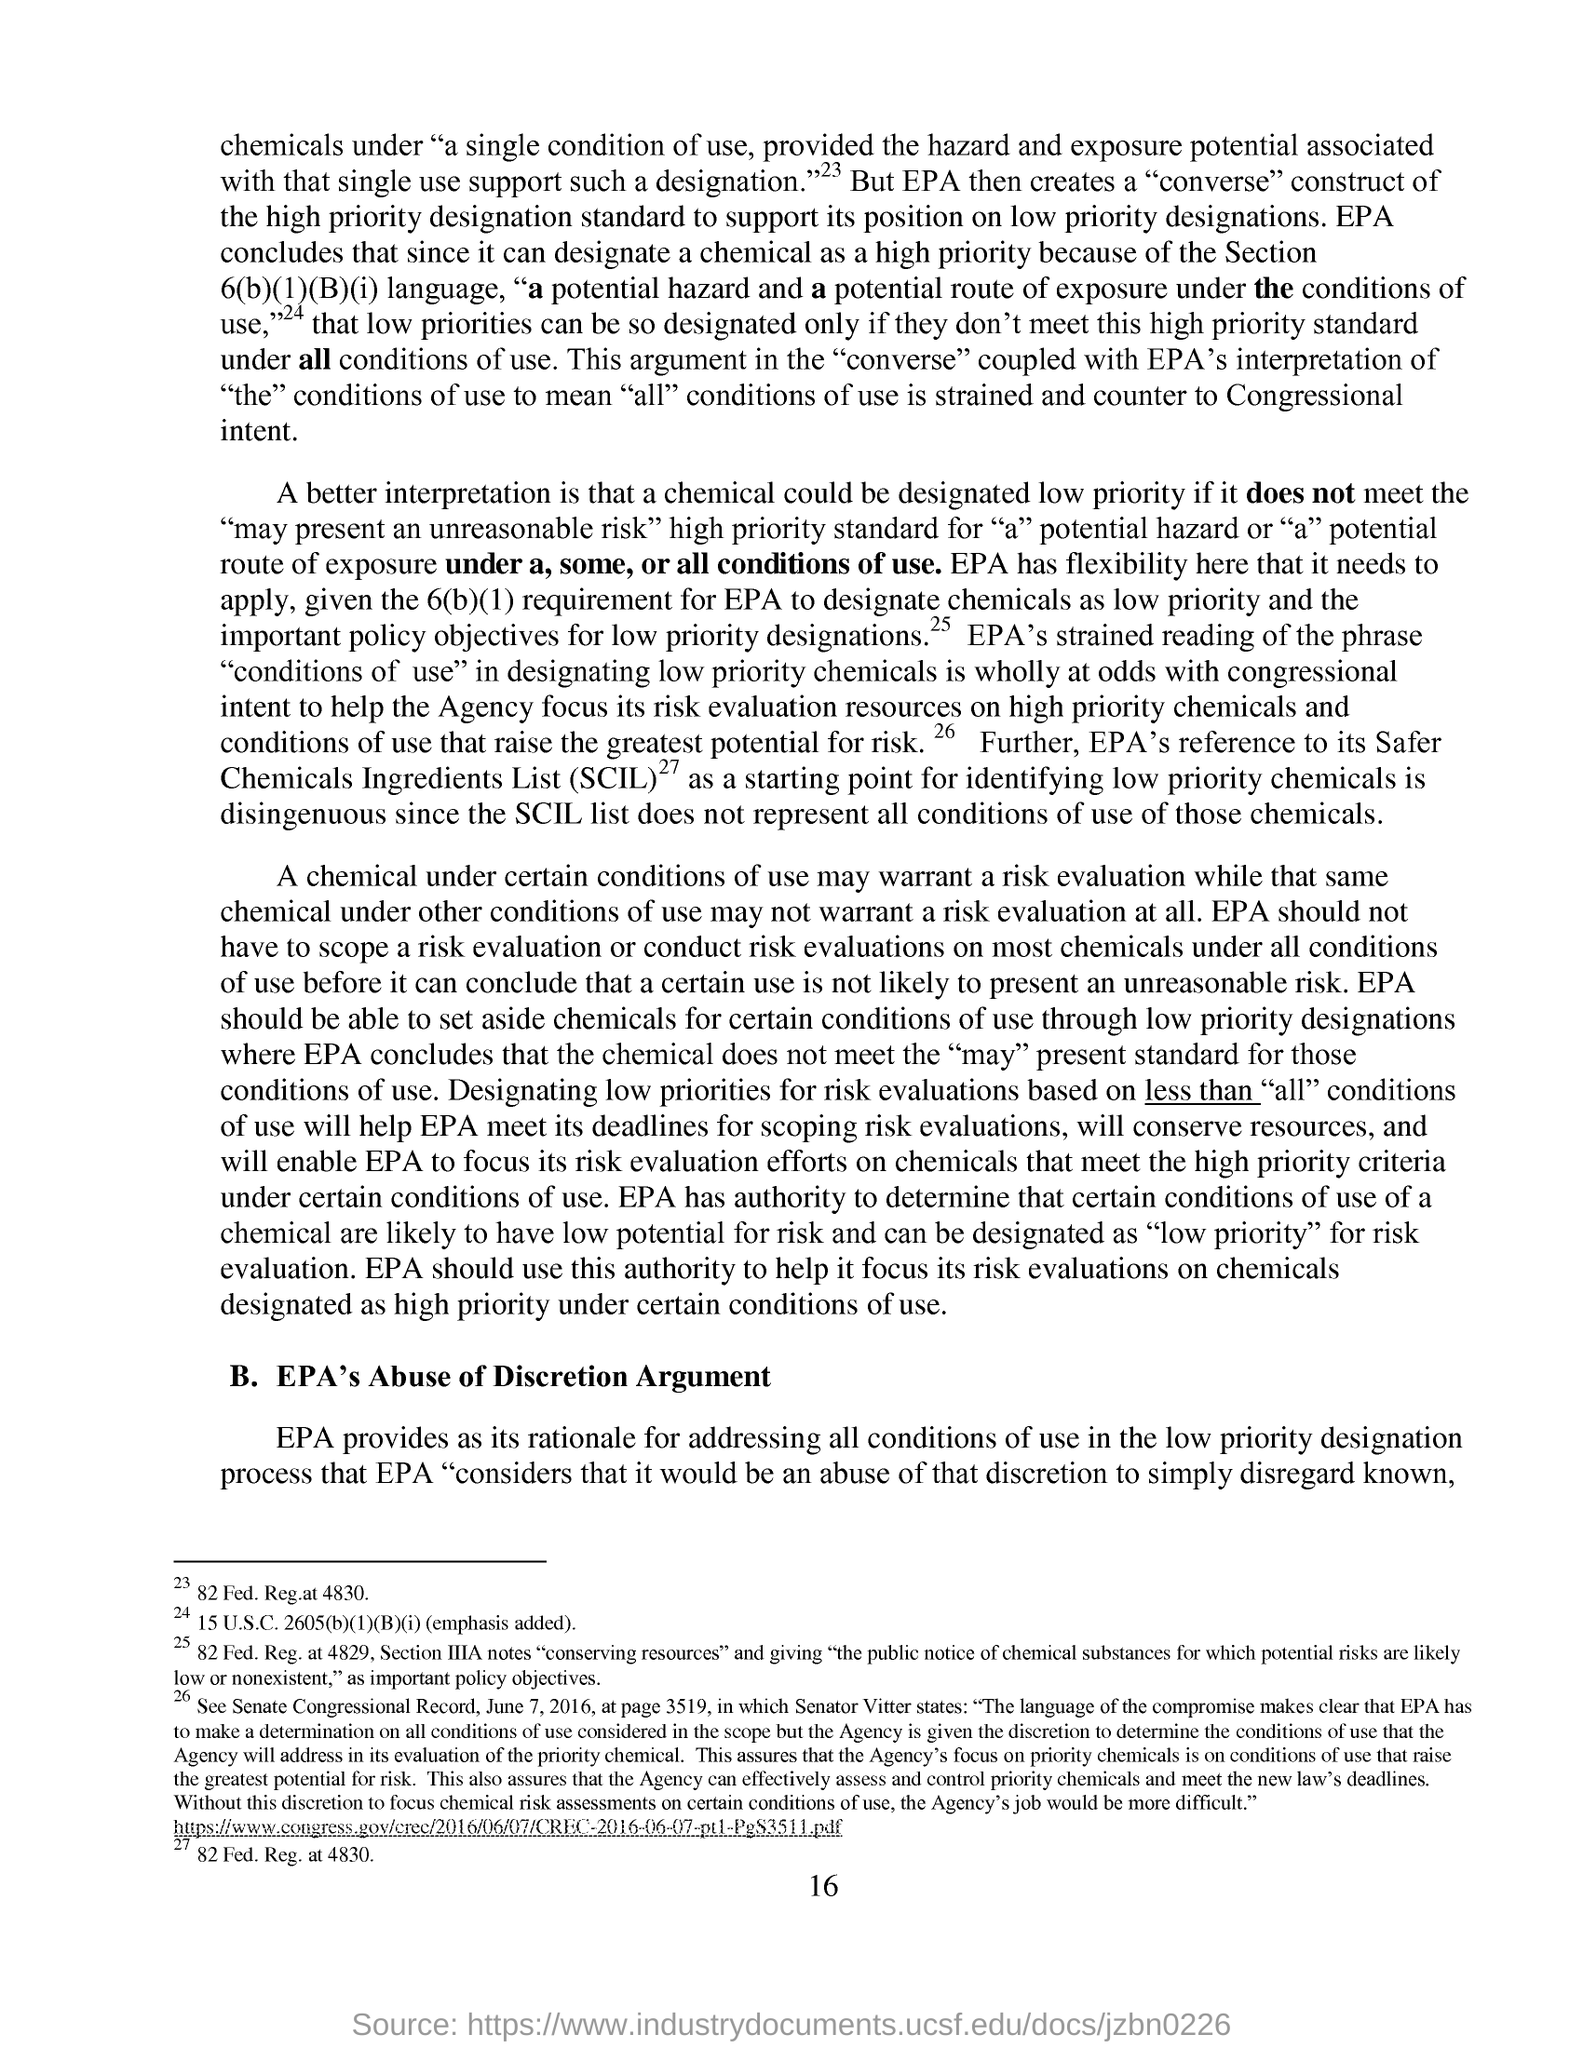What is the fullform of SCIL?
Your answer should be very brief. Safer Chemicals Ingredients List. What is the page no mentioned in this document?
Provide a succinct answer. 16. What is the subheading given in this document?
Your answer should be very brief. EPA's Abuse of Discretion Argument. Which agency can designate a chemical as a high priority?
Give a very brief answer. EPA. 